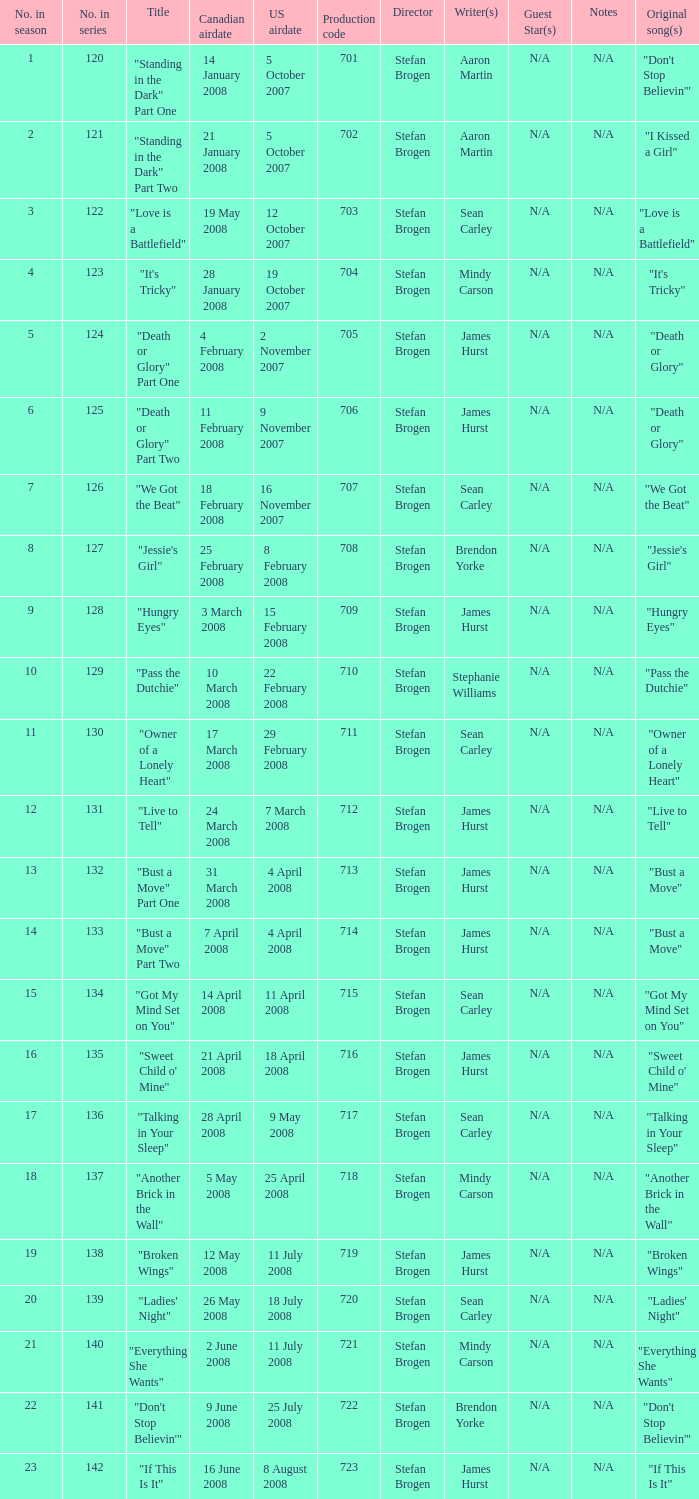The episode titled "don't stop believin'" was what highest number of the season? 22.0. 